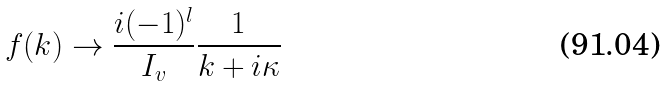<formula> <loc_0><loc_0><loc_500><loc_500>f ( k ) \rightarrow \frac { i ( - 1 ) ^ { l } } { I _ { v } } \frac { 1 } { k + i \kappa }</formula> 